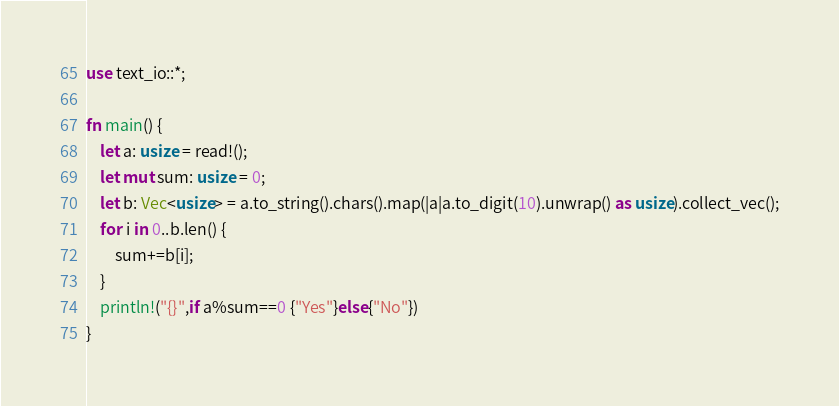<code> <loc_0><loc_0><loc_500><loc_500><_Rust_>use text_io::*;

fn main() {
    let a: usize = read!();
    let mut sum: usize = 0;
    let b: Vec<usize> = a.to_string().chars().map(|a|a.to_digit(10).unwrap() as usize).collect_vec();
    for i in 0..b.len() {
        sum+=b[i];
    }
    println!("{}",if a%sum==0 {"Yes"}else{"No"})
}</code> 